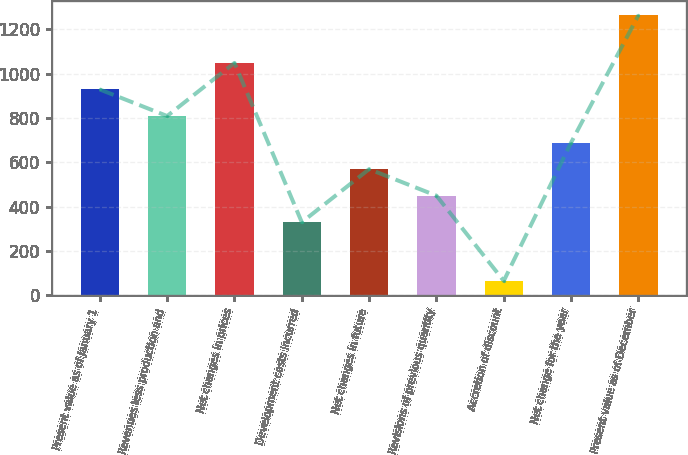Convert chart to OTSL. <chart><loc_0><loc_0><loc_500><loc_500><bar_chart><fcel>Present value as of January 1<fcel>Revenues less production and<fcel>Net changes in prices<fcel>Development costs incurred<fcel>Net changes in future<fcel>Revisions of previous quantity<fcel>Accretion of discount<fcel>Net change for the year<fcel>Present value as of December<nl><fcel>929<fcel>809.26<fcel>1048.74<fcel>330.3<fcel>569.78<fcel>450.04<fcel>65.9<fcel>689.52<fcel>1263.3<nl></chart> 